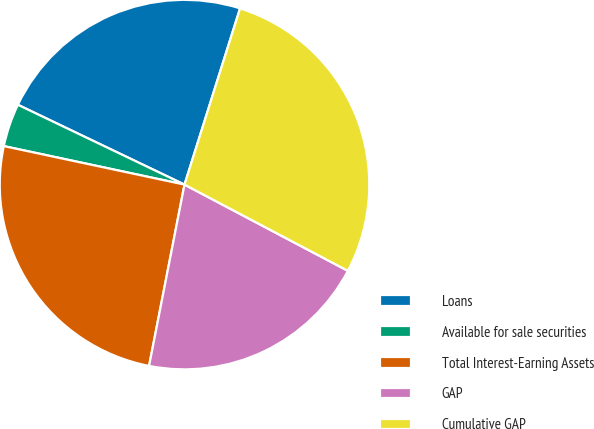Convert chart. <chart><loc_0><loc_0><loc_500><loc_500><pie_chart><fcel>Loans<fcel>Available for sale securities<fcel>Total Interest-Earning Assets<fcel>GAP<fcel>Cumulative GAP<nl><fcel>22.75%<fcel>3.77%<fcel>25.27%<fcel>20.34%<fcel>27.87%<nl></chart> 